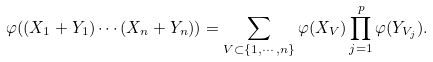Convert formula to latex. <formula><loc_0><loc_0><loc_500><loc_500>\varphi ( ( X _ { 1 } + Y _ { 1 } ) \cdots ( X _ { n } + Y _ { n } ) ) & = \sum _ { V \subset \{ 1 , \cdots , n \} } \varphi ( X _ { V } ) \prod _ { j = 1 } ^ { p } \varphi ( Y _ { V _ { j } } ) .</formula> 